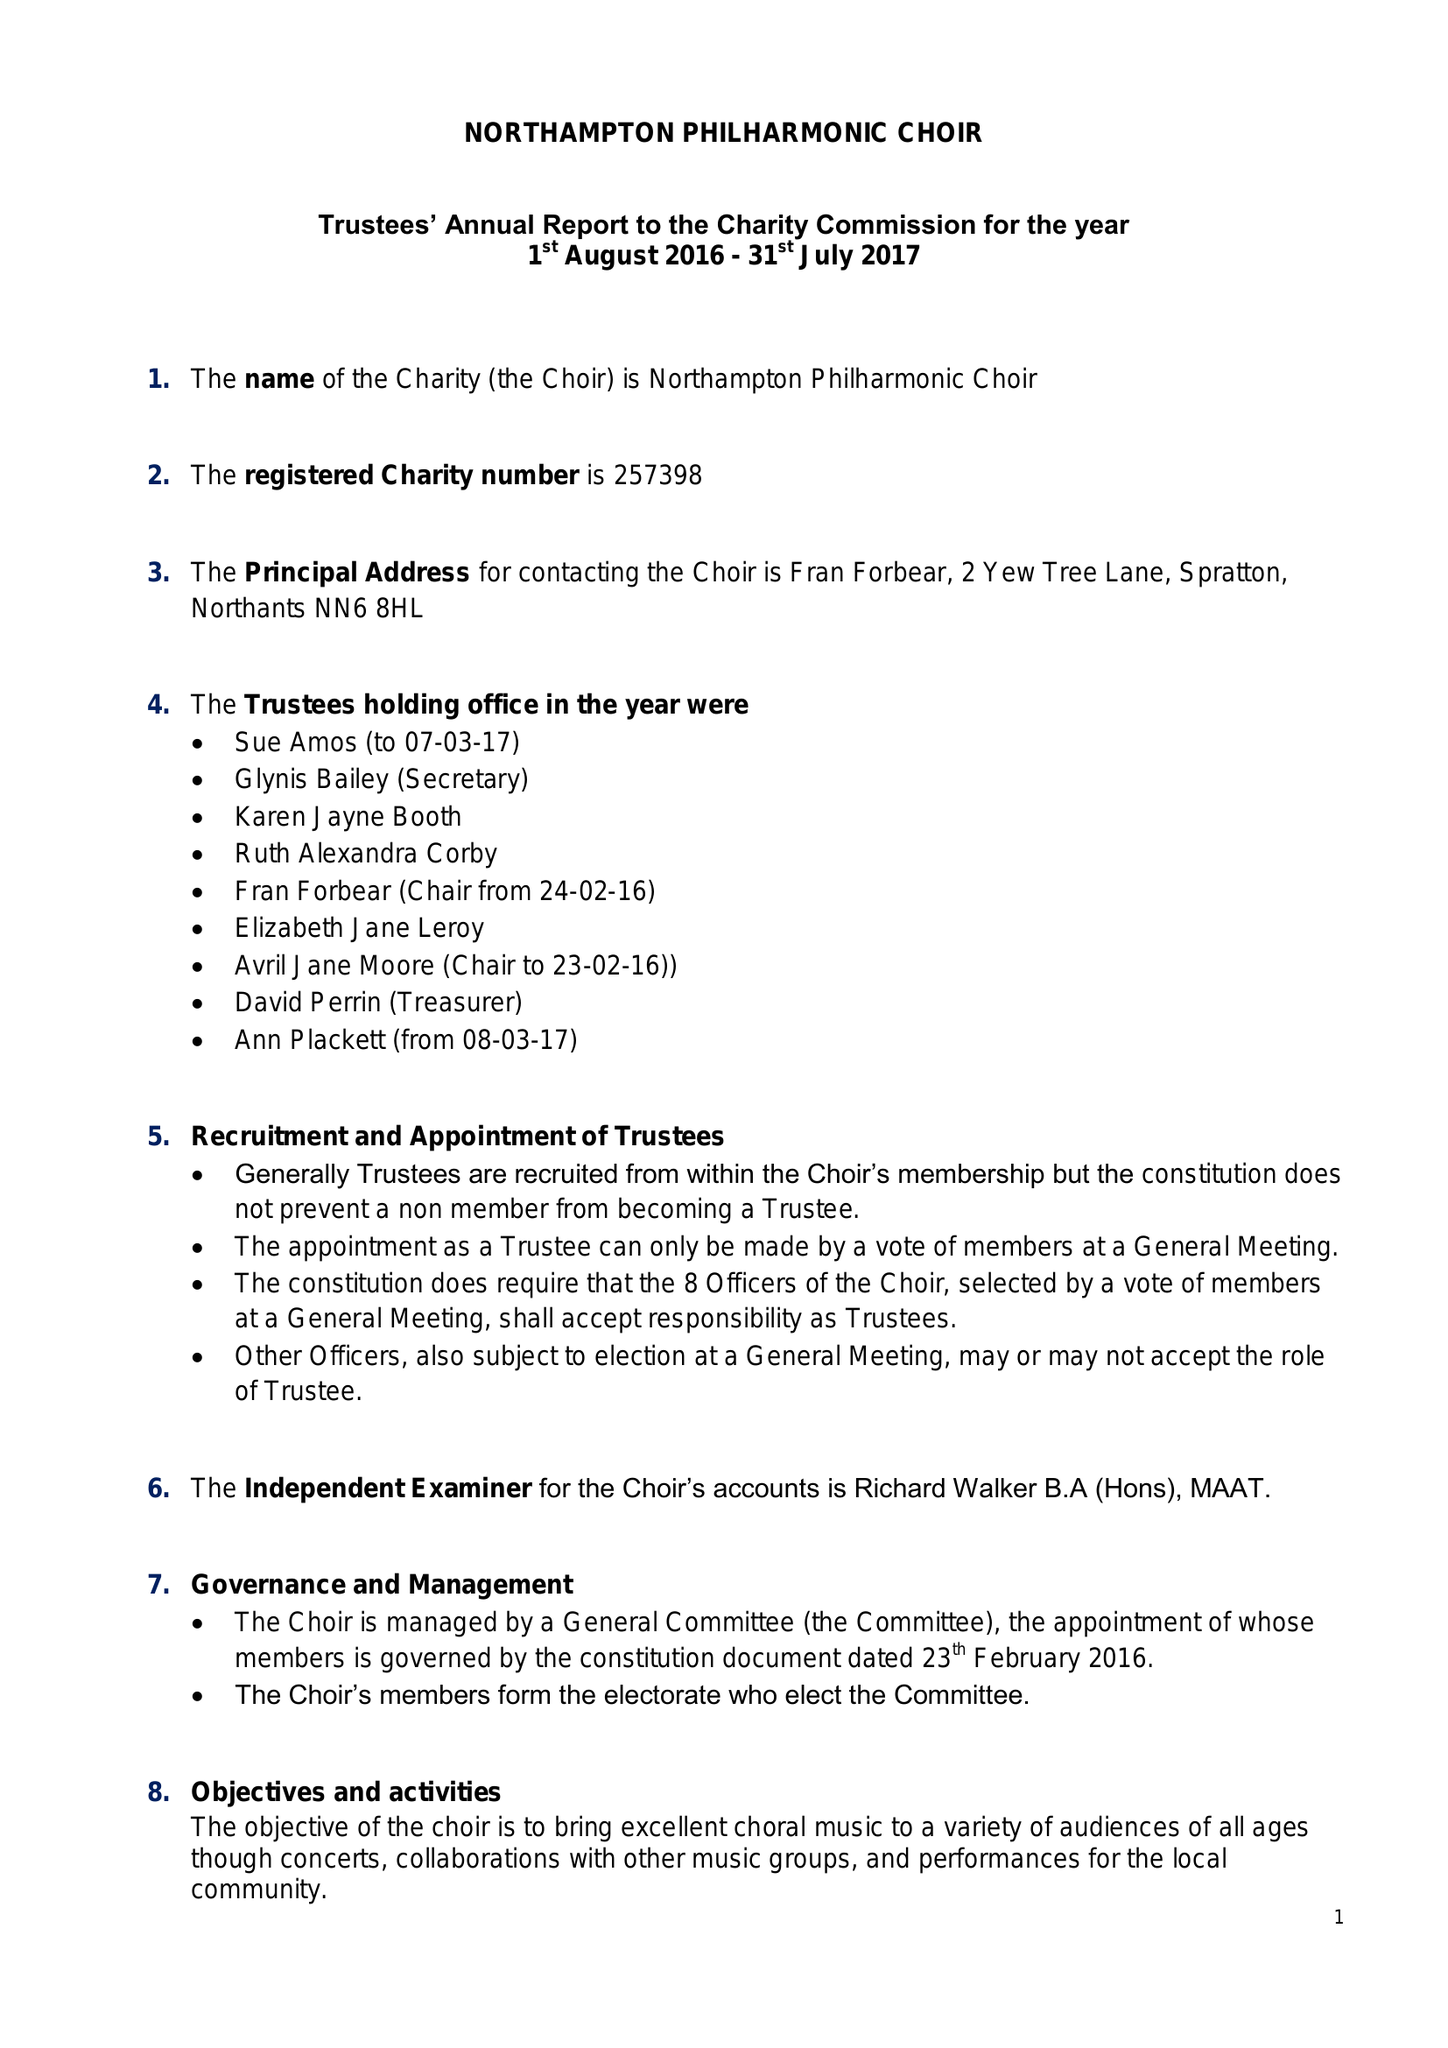What is the value for the address__street_line?
Answer the question using a single word or phrase. 2 YEW TREE LANE 